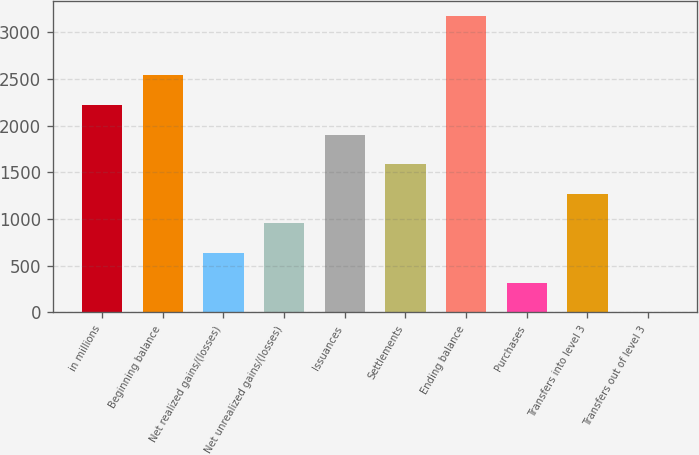Convert chart. <chart><loc_0><loc_0><loc_500><loc_500><bar_chart><fcel>in millions<fcel>Beginning balance<fcel>Net realized gains/(losses)<fcel>Net unrealized gains/(losses)<fcel>Issuances<fcel>Settlements<fcel>Ending balance<fcel>Purchases<fcel>Transfers into level 3<fcel>Transfers out of level 3<nl><fcel>2221.7<fcel>2538.8<fcel>636.2<fcel>953.3<fcel>1904.6<fcel>1587.5<fcel>3173<fcel>319.1<fcel>1270.4<fcel>2<nl></chart> 